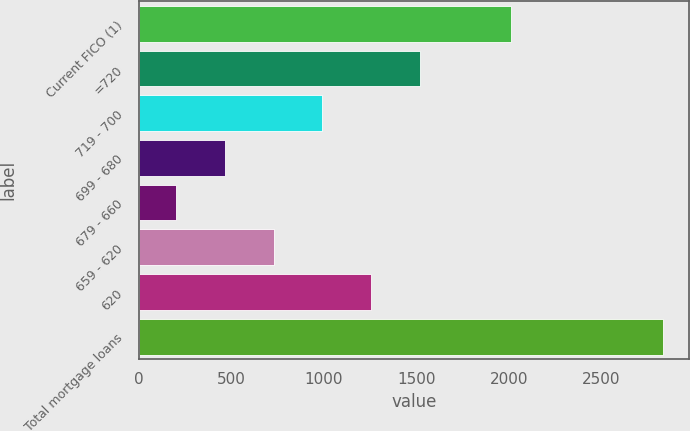Convert chart to OTSL. <chart><loc_0><loc_0><loc_500><loc_500><bar_chart><fcel>Current FICO (1)<fcel>=720<fcel>719 - 700<fcel>699 - 680<fcel>679 - 660<fcel>659 - 620<fcel>620<fcel>Total mortgage loans<nl><fcel>2014<fcel>1518.5<fcel>992.3<fcel>466.1<fcel>203<fcel>729.2<fcel>1255.4<fcel>2834<nl></chart> 